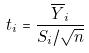Convert formula to latex. <formula><loc_0><loc_0><loc_500><loc_500>t _ { i } = \frac { \overline { Y } _ { i } } { S _ { i } / \sqrt { n } }</formula> 